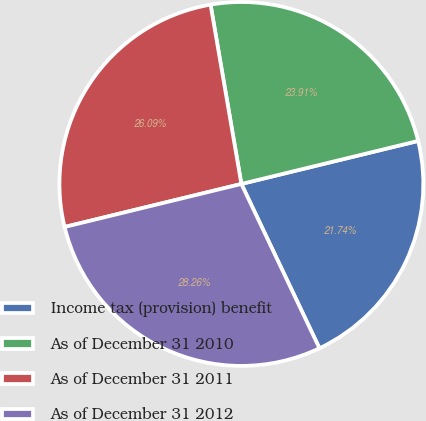Convert chart to OTSL. <chart><loc_0><loc_0><loc_500><loc_500><pie_chart><fcel>Income tax (provision) benefit<fcel>As of December 31 2010<fcel>As of December 31 2011<fcel>As of December 31 2012<nl><fcel>21.74%<fcel>23.91%<fcel>26.09%<fcel>28.26%<nl></chart> 